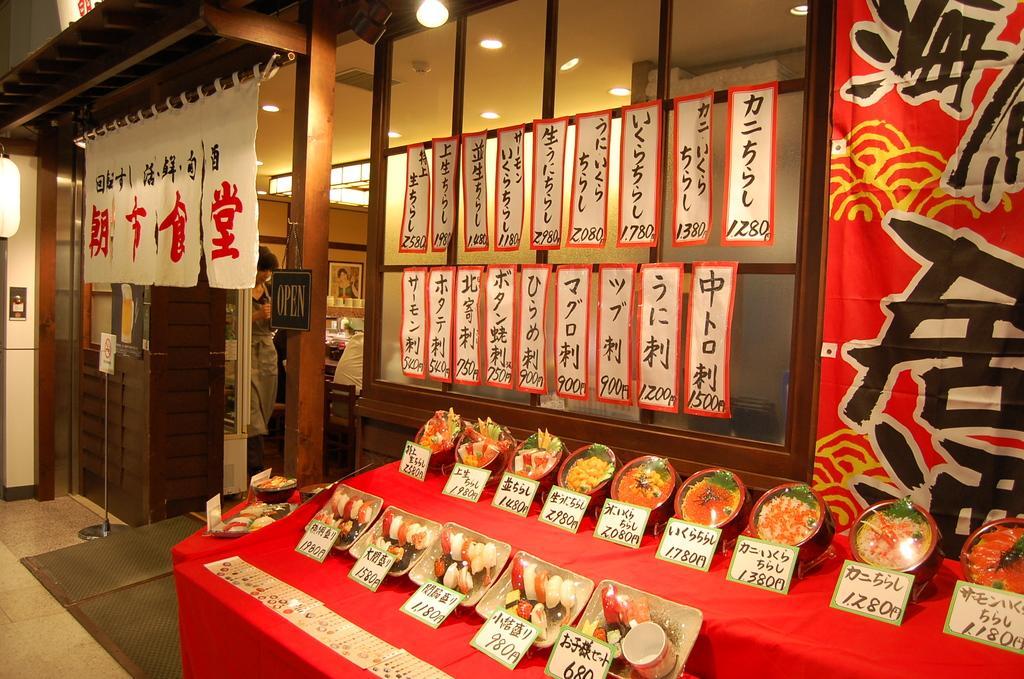How would you summarize this image in a sentence or two? In this picture I can see food items on the plates and in the bowls and there are price boards on the tables, there are lights, banners, there is a person standing, there are chairs, there is a frame attached to the wall and there are some objects. 